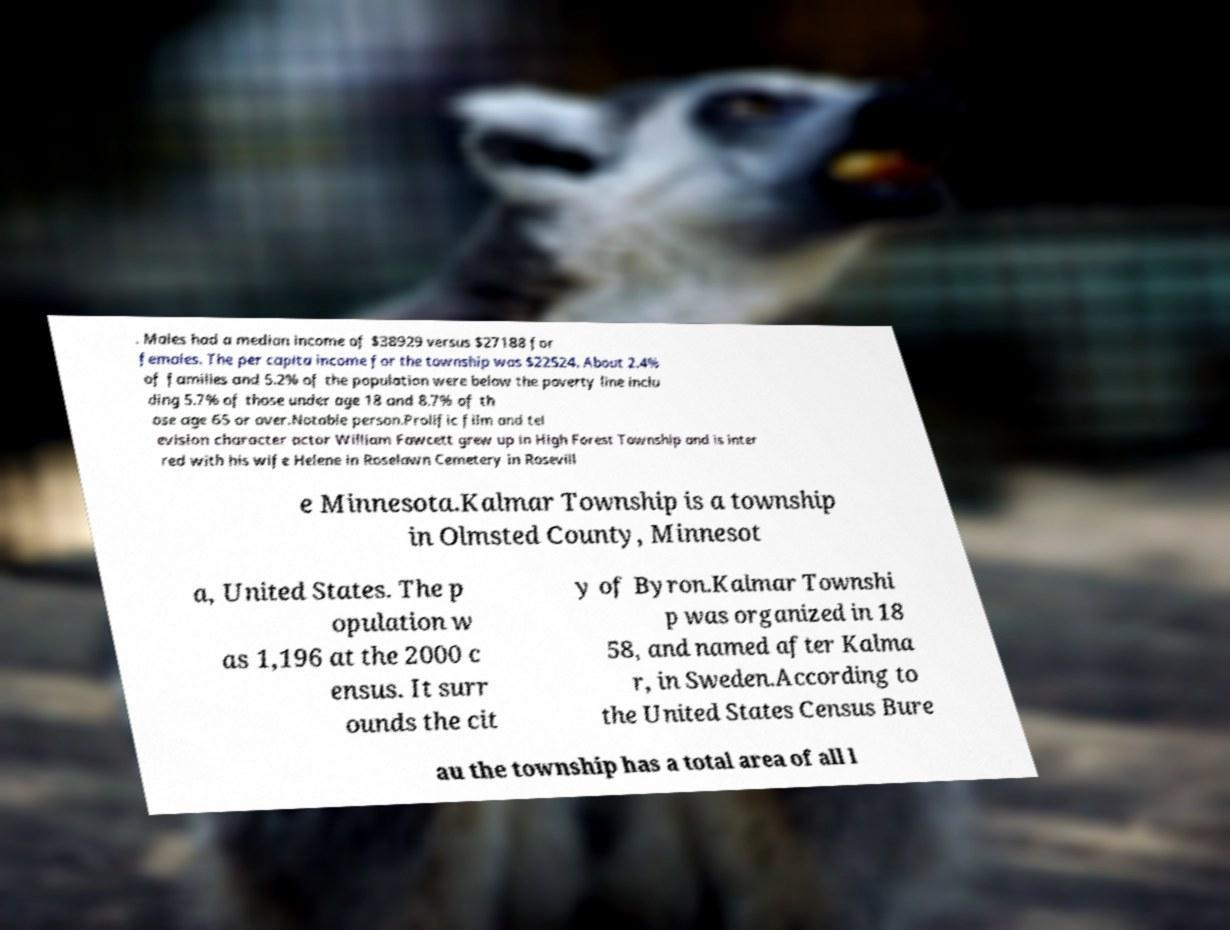Please read and relay the text visible in this image. What does it say? . Males had a median income of $38929 versus $27188 for females. The per capita income for the township was $22524. About 2.4% of families and 5.2% of the population were below the poverty line inclu ding 5.7% of those under age 18 and 8.7% of th ose age 65 or over.Notable person.Prolific film and tel evision character actor William Fawcett grew up in High Forest Township and is inter red with his wife Helene in Roselawn Cemetery in Rosevill e Minnesota.Kalmar Township is a township in Olmsted County, Minnesot a, United States. The p opulation w as 1,196 at the 2000 c ensus. It surr ounds the cit y of Byron.Kalmar Townshi p was organized in 18 58, and named after Kalma r, in Sweden.According to the United States Census Bure au the township has a total area of all l 